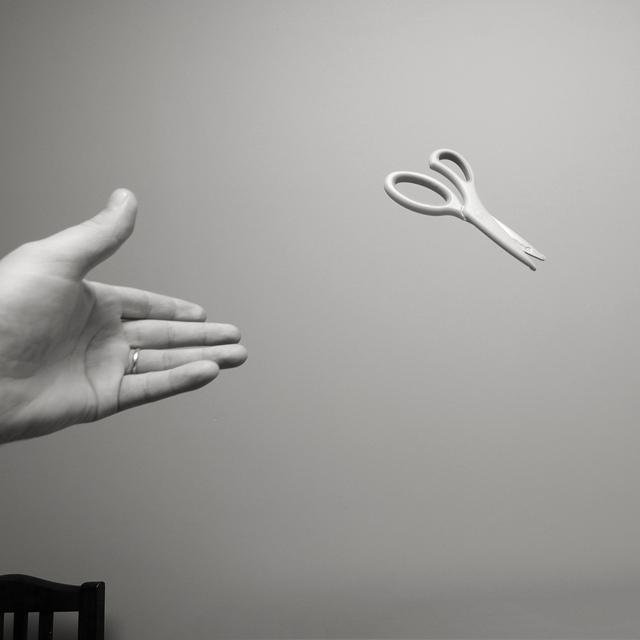How will the scissors move next? Please explain your reasoning. arc downwards. Based on the location of the scissors they likely originated from the hand as they could not appear in that location naturally. if moved from the hand and no longer attached to anything, gravity will begin to pull them down. 